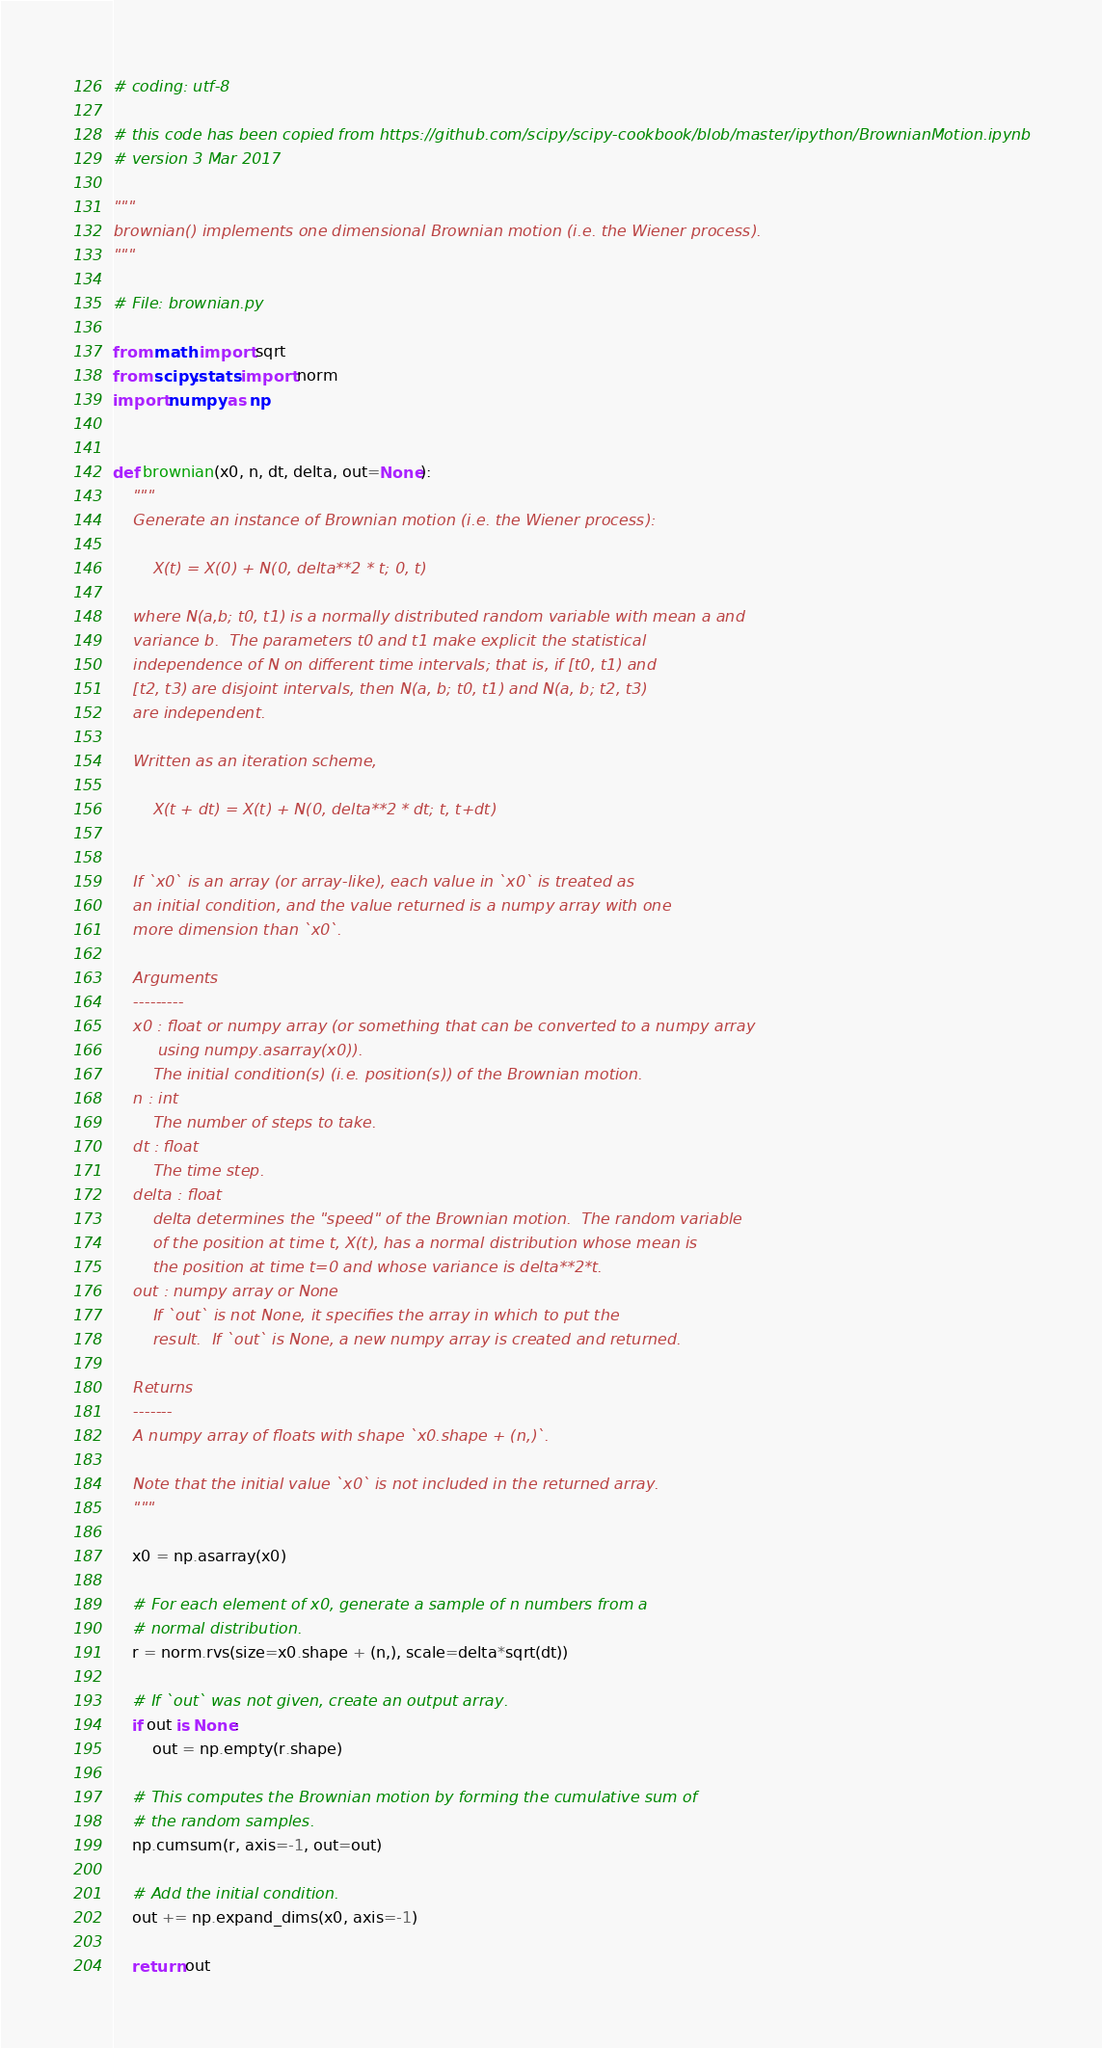<code> <loc_0><loc_0><loc_500><loc_500><_Python_>
# coding: utf-8

# this code has been copied from https://github.com/scipy/scipy-cookbook/blob/master/ipython/BrownianMotion.ipynb
# version 3 Mar 2017

"""
brownian() implements one dimensional Brownian motion (i.e. the Wiener process).
"""

# File: brownian.py

from math import sqrt
from scipy.stats import norm
import numpy as np


def brownian(x0, n, dt, delta, out=None):
    """
    Generate an instance of Brownian motion (i.e. the Wiener process):

        X(t) = X(0) + N(0, delta**2 * t; 0, t)

    where N(a,b; t0, t1) is a normally distributed random variable with mean a and
    variance b.  The parameters t0 and t1 make explicit the statistical
    independence of N on different time intervals; that is, if [t0, t1) and
    [t2, t3) are disjoint intervals, then N(a, b; t0, t1) and N(a, b; t2, t3)
    are independent.
    
    Written as an iteration scheme,

        X(t + dt) = X(t) + N(0, delta**2 * dt; t, t+dt)


    If `x0` is an array (or array-like), each value in `x0` is treated as
    an initial condition, and the value returned is a numpy array with one
    more dimension than `x0`.

    Arguments
    ---------
    x0 : float or numpy array (or something that can be converted to a numpy array
         using numpy.asarray(x0)).
        The initial condition(s) (i.e. position(s)) of the Brownian motion.
    n : int
        The number of steps to take.
    dt : float
        The time step.
    delta : float
        delta determines the "speed" of the Brownian motion.  The random variable
        of the position at time t, X(t), has a normal distribution whose mean is
        the position at time t=0 and whose variance is delta**2*t.
    out : numpy array or None
        If `out` is not None, it specifies the array in which to put the
        result.  If `out` is None, a new numpy array is created and returned.

    Returns
    -------
    A numpy array of floats with shape `x0.shape + (n,)`.
    
    Note that the initial value `x0` is not included in the returned array.
    """

    x0 = np.asarray(x0)

    # For each element of x0, generate a sample of n numbers from a
    # normal distribution.
    r = norm.rvs(size=x0.shape + (n,), scale=delta*sqrt(dt))

    # If `out` was not given, create an output array.
    if out is None:
        out = np.empty(r.shape)

    # This computes the Brownian motion by forming the cumulative sum of
    # the random samples. 
    np.cumsum(r, axis=-1, out=out)

    # Add the initial condition.
    out += np.expand_dims(x0, axis=-1)

    return out

</code> 